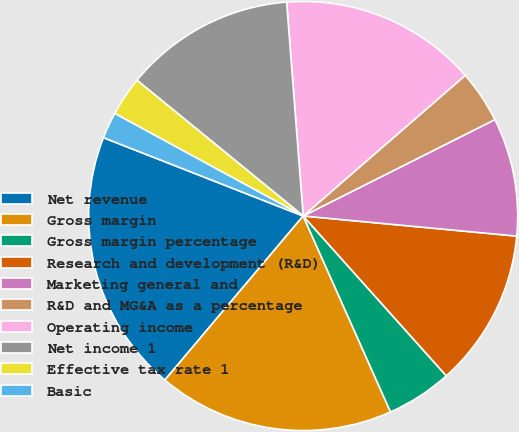Convert chart. <chart><loc_0><loc_0><loc_500><loc_500><pie_chart><fcel>Net revenue<fcel>Gross margin<fcel>Gross margin percentage<fcel>Research and development (R&D)<fcel>Marketing general and<fcel>R&D and MG&A as a percentage<fcel>Operating income<fcel>Net income 1<fcel>Effective tax rate 1<fcel>Basic<nl><fcel>19.8%<fcel>17.82%<fcel>4.95%<fcel>11.88%<fcel>8.91%<fcel>3.96%<fcel>14.85%<fcel>12.87%<fcel>2.97%<fcel>1.98%<nl></chart> 